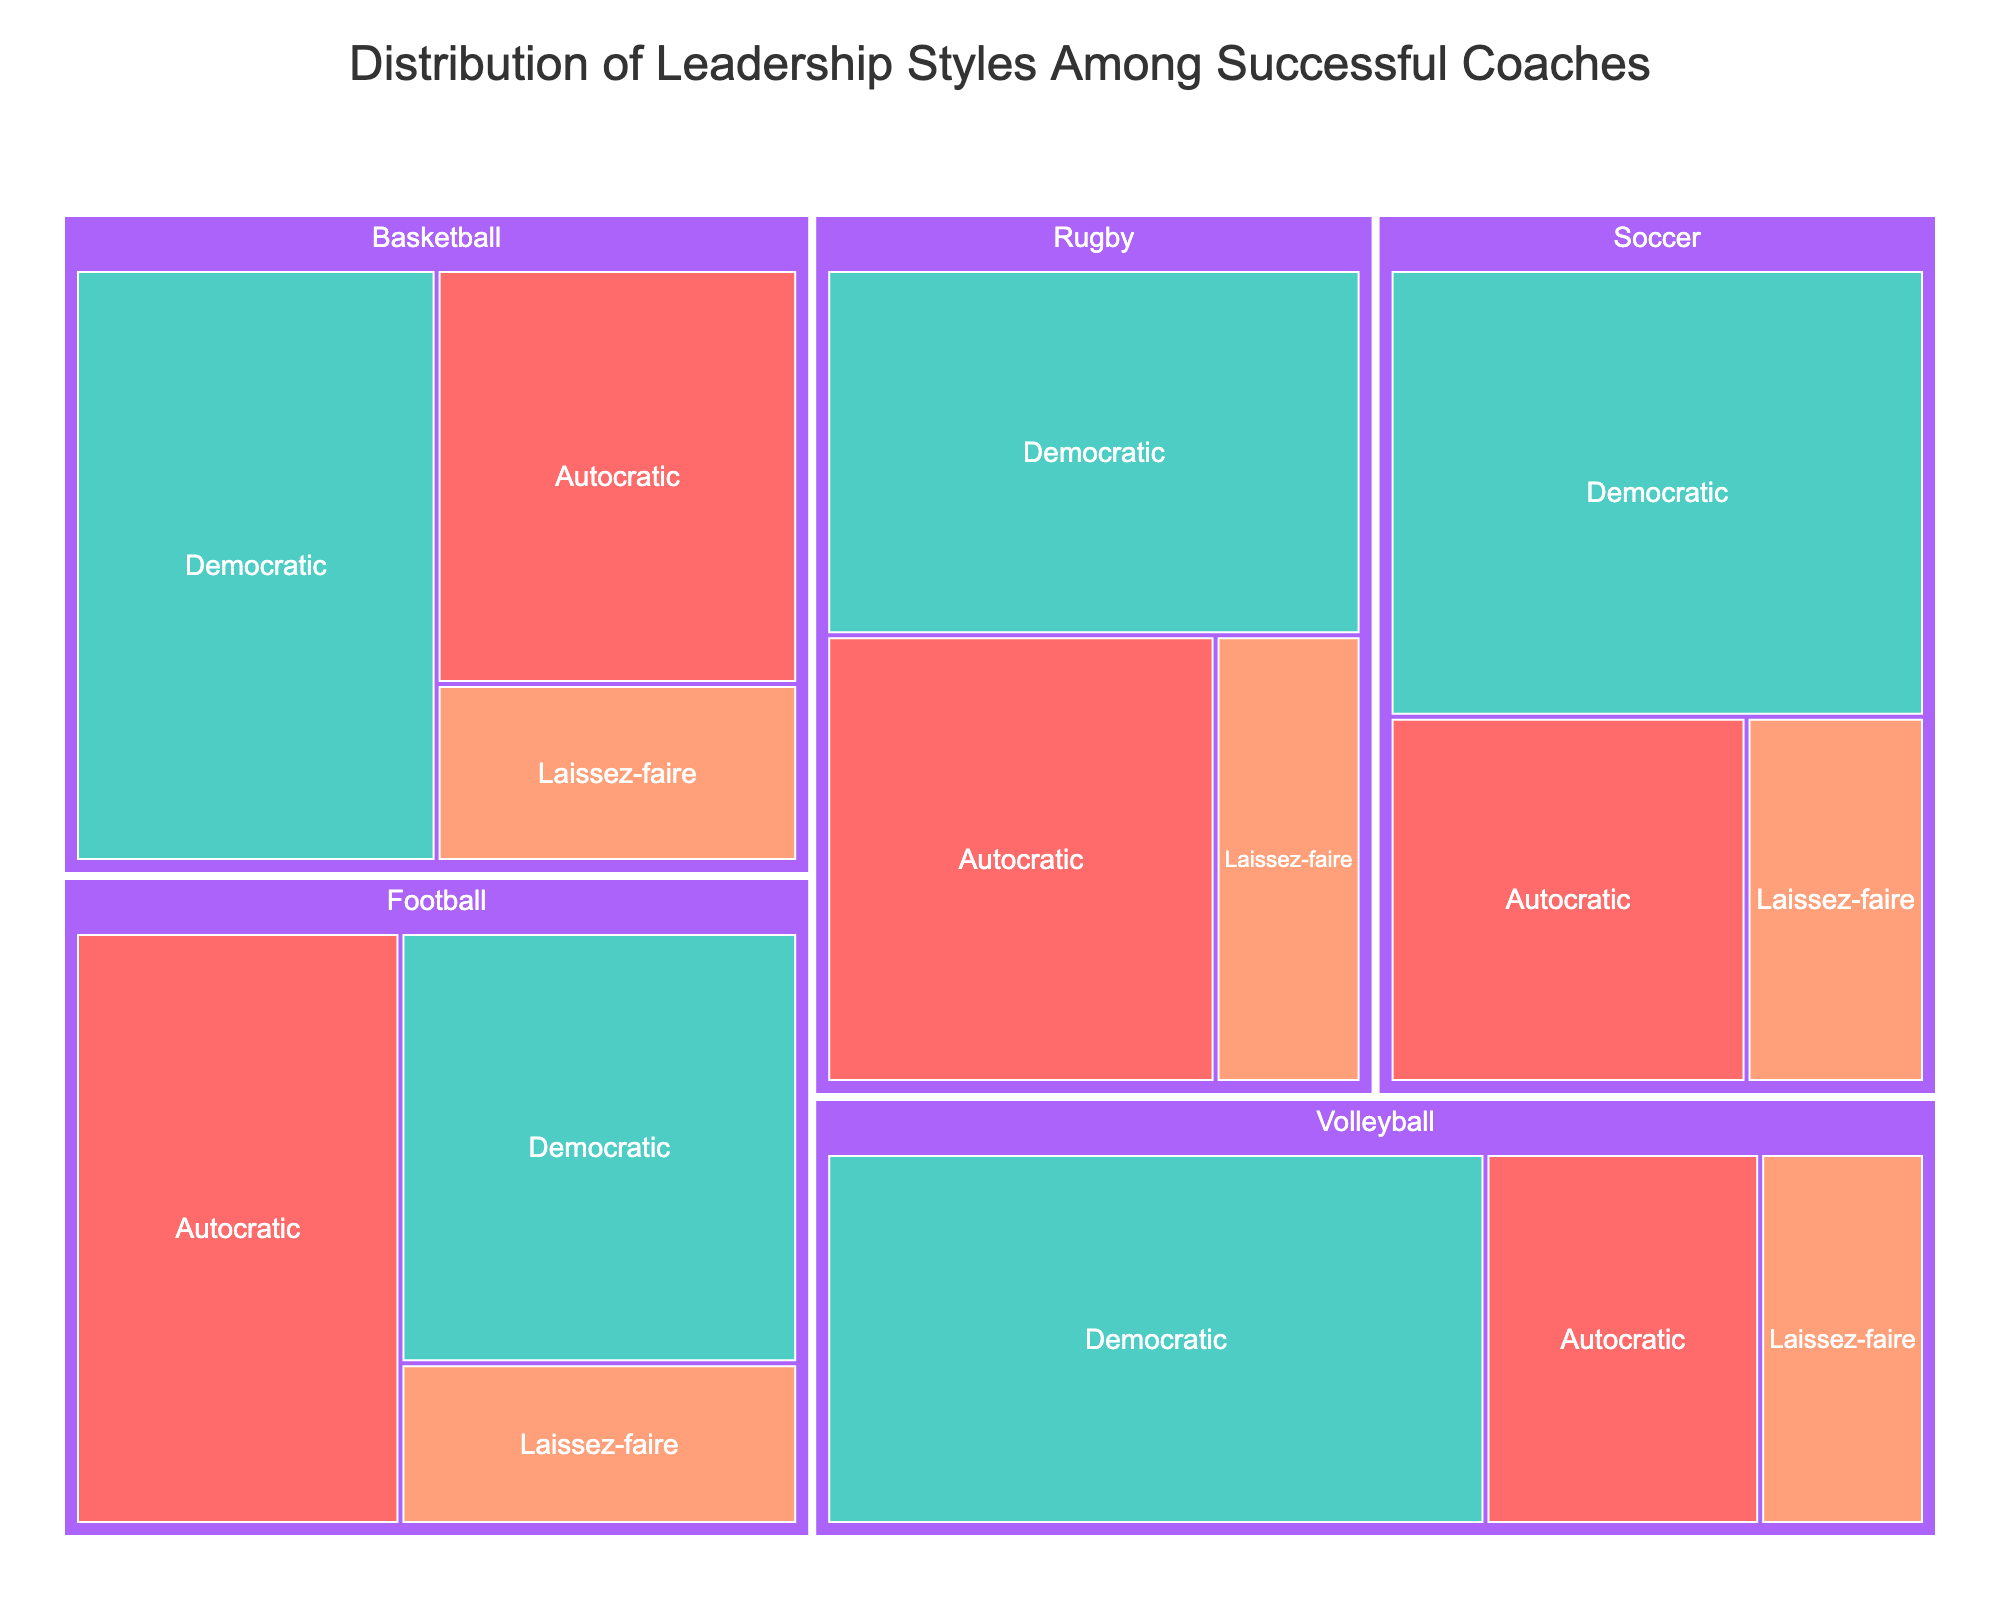What is the title of the treemap? The title of the treemap is displayed at the top of the figure and it reads "Distribution of Leadership Styles Among Successful Coaches".
Answer: Distribution of Leadership Styles Among Successful Coaches Which sport has the highest percentage of Democratic leadership style? To find the sport with the highest percentage of Democratic leadership style, inspect the greenish area labeled "Democratic" within each sport. Volleyball has the greenish area that takes up 60% of its section.
Answer: Volleyball What is the total percentage of Autocratic leadership style across all sports? Summing up the Autocratic percentages for Basketball (35%), Football (45%), Soccer (30%), Volleyball (25%), and Rugby (40%) gives 35 + 45 + 30 + 25 + 40 = 175%.
Answer: 175% How does the percentage of Laissez-faire leadership style in Volleyball compare to that in Soccer? Both Volleyball and Soccer have the Laissez-faire percentage displayed as 15%. By comparing the areas labeled "Laissez-faire" within Volleyball and Soccer, it is clear they are equivalent.
Answer: Equal Which sport shows the most balanced distribution between the different leadership styles? The sport with the most balanced distribution would have similar-sized areas for the different leadership styles. Inspecting each sport, Football has the closest proportions: 45% Autocratic, 40% Democratic, and 15% Laissez-faire.
Answer: Football Is the Democratic leadership style always more prevalent than Laissez-faire across all sports? By checking each sport's section, the percentage of Democratic leadership style (greenish) is indeed always larger than that of Laissez-faire (orange) in Basketball, Football, Soccer, Volleyball, and Rugby.
Answer: Yes What percentage of successful Rugby coaches use a Democratic leadership style? Within the Rugby section of the treemap, the greenish area labeled "Democratic" represents 45%.
Answer: 45% Among the listed sports, which shows the largest single percentage for any leadership style? The largest single percentage for any leadership style within a sport is found by inspecting the largest area in the treemap. Volleyball's Democratic leadership style occupies 60%.
Answer: Volleyball's Democratic at 60% How much more prevalent is the Autocratic leadership style in Football compared to Volleyball? Football's Autocratic leadership style is 45%, while Volleyball's is 25%. The difference is 45 - 25 = 20%.
Answer: 20% Which leadership style is the least common among successful Basketball coaches? Looking at the sections within Basketball, the smallest area represents Laissez-faire with 15%.
Answer: Laissez-faire 